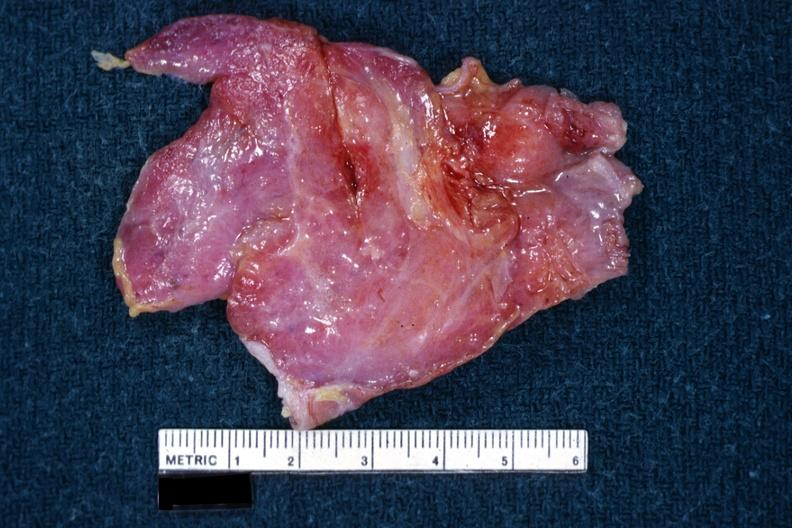s normal ovary present?
Answer the question using a single word or phrase. No 